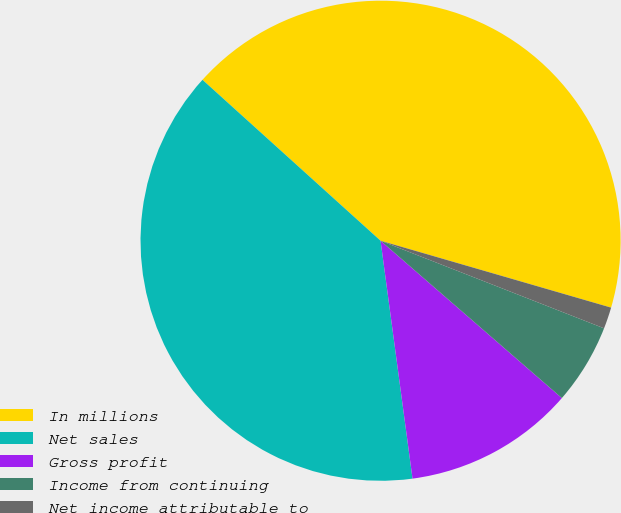Convert chart to OTSL. <chart><loc_0><loc_0><loc_500><loc_500><pie_chart><fcel>In millions<fcel>Net sales<fcel>Gross profit<fcel>Income from continuing<fcel>Net income attributable to<nl><fcel>42.8%<fcel>38.82%<fcel>11.5%<fcel>5.43%<fcel>1.45%<nl></chart> 